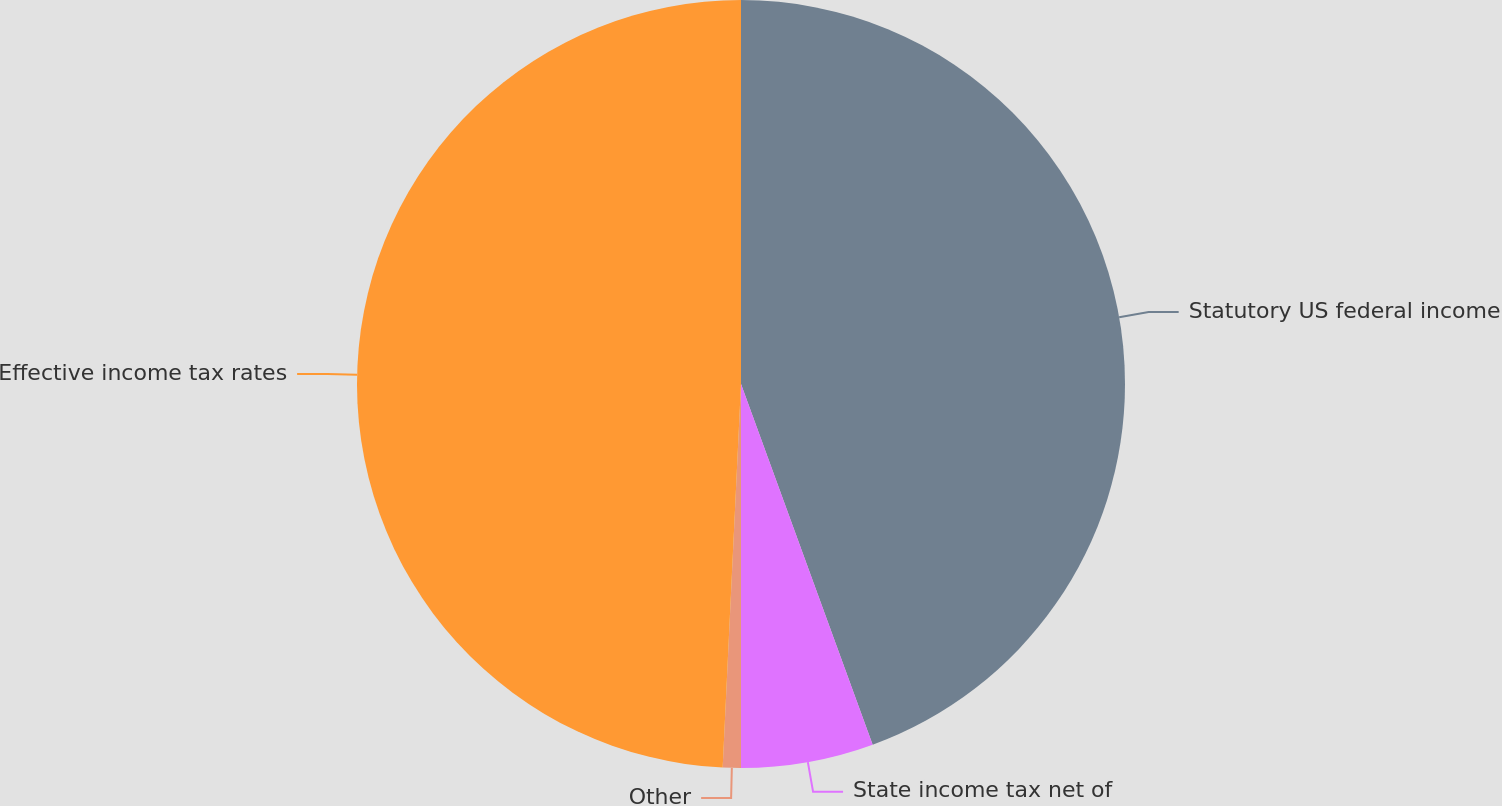Convert chart to OTSL. <chart><loc_0><loc_0><loc_500><loc_500><pie_chart><fcel>Statutory US federal income<fcel>State income tax net of<fcel>Other<fcel>Effective income tax rates<nl><fcel>44.43%<fcel>5.57%<fcel>0.76%<fcel>49.24%<nl></chart> 